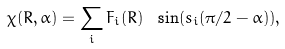<formula> <loc_0><loc_0><loc_500><loc_500>\chi ( R , \alpha ) = \sum _ { i } F _ { i } ( R ) \ \sin ( s _ { i } ( \pi / 2 - \alpha ) ) ,</formula> 